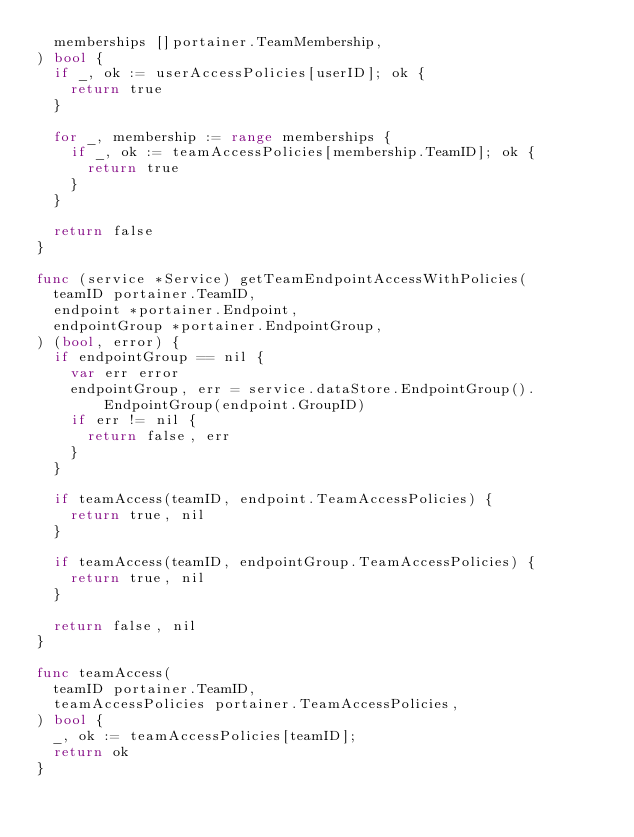<code> <loc_0><loc_0><loc_500><loc_500><_Go_>	memberships []portainer.TeamMembership,
) bool {
	if _, ok := userAccessPolicies[userID]; ok {
		return true
	}

	for _, membership := range memberships {
		if _, ok := teamAccessPolicies[membership.TeamID]; ok {
			return true
		}
	}

	return false
}

func (service *Service) getTeamEndpointAccessWithPolicies(
	teamID portainer.TeamID,
	endpoint *portainer.Endpoint,
	endpointGroup *portainer.EndpointGroup,
) (bool, error) {
	if endpointGroup == nil {
		var err error
		endpointGroup, err = service.dataStore.EndpointGroup().EndpointGroup(endpoint.GroupID)
		if err != nil {
			return false, err
		}
	}

	if teamAccess(teamID, endpoint.TeamAccessPolicies) {
		return true, nil
	}

	if teamAccess(teamID, endpointGroup.TeamAccessPolicies) {
		return true, nil
	}

	return false, nil
}

func teamAccess(
	teamID portainer.TeamID,
	teamAccessPolicies portainer.TeamAccessPolicies,
) bool {
	_, ok := teamAccessPolicies[teamID];
	return ok
}</code> 